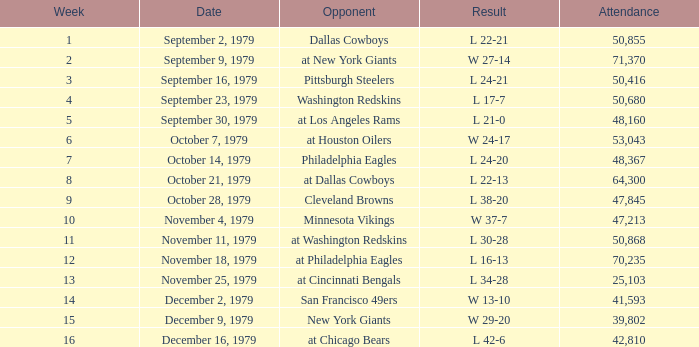What result in a week over 2 occurred with an attendance greater than 53,043 on November 18, 1979? L 16-13. 